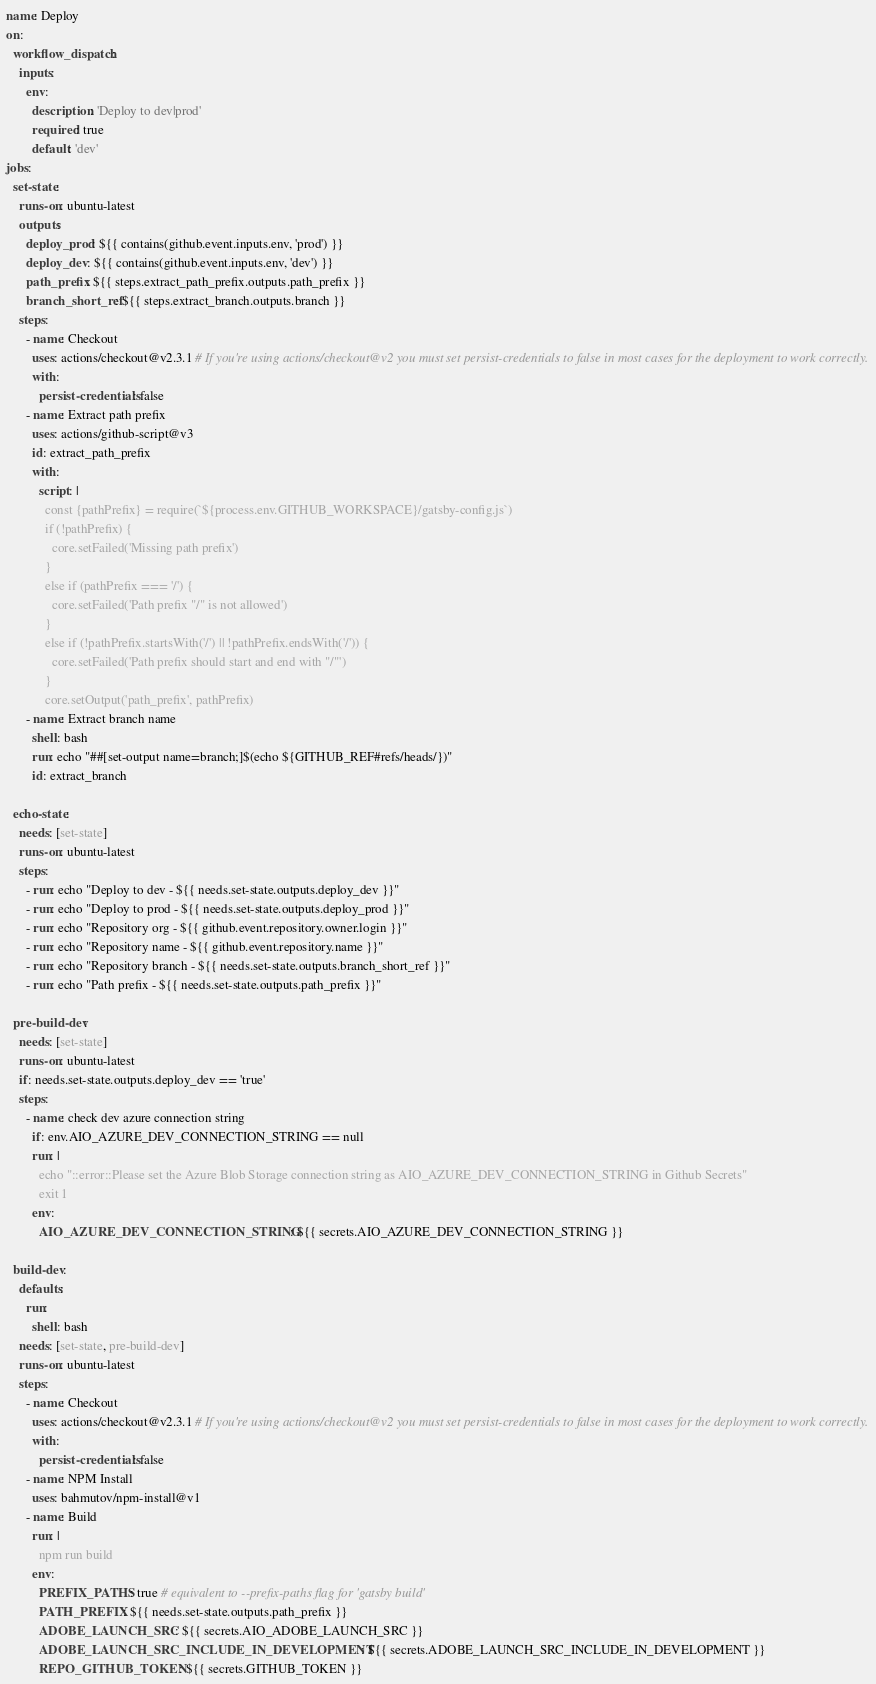Convert code to text. <code><loc_0><loc_0><loc_500><loc_500><_YAML_>name: Deploy
on:
  workflow_dispatch:
    inputs:
      env:
        description: 'Deploy to dev|prod'
        required: true
        default: 'dev'
jobs:
  set-state:
    runs-on: ubuntu-latest
    outputs:
      deploy_prod: ${{ contains(github.event.inputs.env, 'prod') }}
      deploy_dev: ${{ contains(github.event.inputs.env, 'dev') }}
      path_prefix: ${{ steps.extract_path_prefix.outputs.path_prefix }}
      branch_short_ref: ${{ steps.extract_branch.outputs.branch }}
    steps:
      - name: Checkout
        uses: actions/checkout@v2.3.1 # If you're using actions/checkout@v2 you must set persist-credentials to false in most cases for the deployment to work correctly.
        with:
          persist-credentials: false
      - name: Extract path prefix
        uses: actions/github-script@v3
        id: extract_path_prefix
        with:
          script: |
            const {pathPrefix} = require(`${process.env.GITHUB_WORKSPACE}/gatsby-config.js`)
            if (!pathPrefix) {
              core.setFailed('Missing path prefix')
            }
            else if (pathPrefix === '/') {
              core.setFailed('Path prefix "/" is not allowed')
            }
            else if (!pathPrefix.startsWith('/') || !pathPrefix.endsWith('/')) {
              core.setFailed('Path prefix should start and end with "/"')
            }
            core.setOutput('path_prefix', pathPrefix)
      - name: Extract branch name
        shell: bash
        run: echo "##[set-output name=branch;]$(echo ${GITHUB_REF#refs/heads/})"
        id: extract_branch

  echo-state:
    needs: [set-state]
    runs-on: ubuntu-latest
    steps:
      - run: echo "Deploy to dev - ${{ needs.set-state.outputs.deploy_dev }}"
      - run: echo "Deploy to prod - ${{ needs.set-state.outputs.deploy_prod }}"
      - run: echo "Repository org - ${{ github.event.repository.owner.login }}"
      - run: echo "Repository name - ${{ github.event.repository.name }}"
      - run: echo "Repository branch - ${{ needs.set-state.outputs.branch_short_ref }}"
      - run: echo "Path prefix - ${{ needs.set-state.outputs.path_prefix }}"

  pre-build-dev:
    needs: [set-state]
    runs-on: ubuntu-latest
    if: needs.set-state.outputs.deploy_dev == 'true'
    steps:
      - name: check dev azure connection string
        if: env.AIO_AZURE_DEV_CONNECTION_STRING == null
        run: |
          echo "::error::Please set the Azure Blob Storage connection string as AIO_AZURE_DEV_CONNECTION_STRING in Github Secrets"
          exit 1
        env:
          AIO_AZURE_DEV_CONNECTION_STRING: ${{ secrets.AIO_AZURE_DEV_CONNECTION_STRING }}

  build-dev:
    defaults:
      run:
        shell: bash
    needs: [set-state, pre-build-dev]
    runs-on: ubuntu-latest
    steps:
      - name: Checkout
        uses: actions/checkout@v2.3.1 # If you're using actions/checkout@v2 you must set persist-credentials to false in most cases for the deployment to work correctly.
        with:
          persist-credentials: false
      - name: NPM Install
        uses: bahmutov/npm-install@v1
      - name: Build
        run: |
          npm run build
        env:
          PREFIX_PATHS: true # equivalent to --prefix-paths flag for 'gatsby build'
          PATH_PREFIX: ${{ needs.set-state.outputs.path_prefix }}
          ADOBE_LAUNCH_SRC: ${{ secrets.AIO_ADOBE_LAUNCH_SRC }}
          ADOBE_LAUNCH_SRC_INCLUDE_IN_DEVELOPMENT: ${{ secrets.ADOBE_LAUNCH_SRC_INCLUDE_IN_DEVELOPMENT }}
          REPO_GITHUB_TOKEN: ${{ secrets.GITHUB_TOKEN }}</code> 